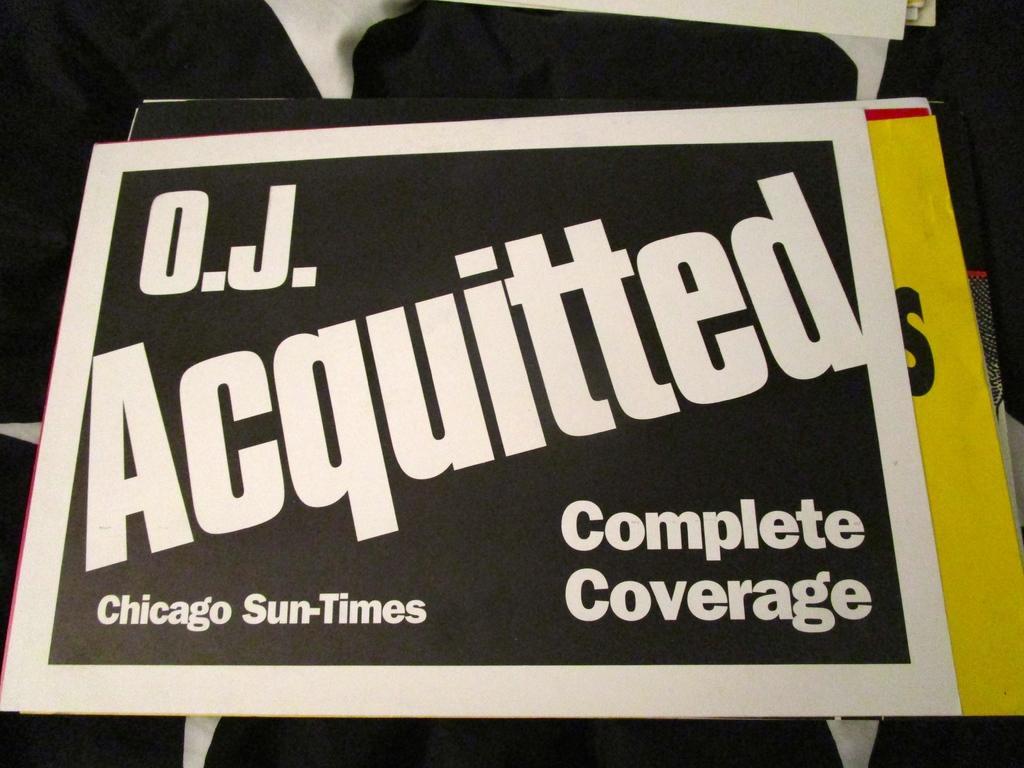Please provide a concise description of this image. In this image I can see few boards and on these words I can see something is written. I can see colour of these boards are black and yellow. I can also see few black colour things under these boards. 